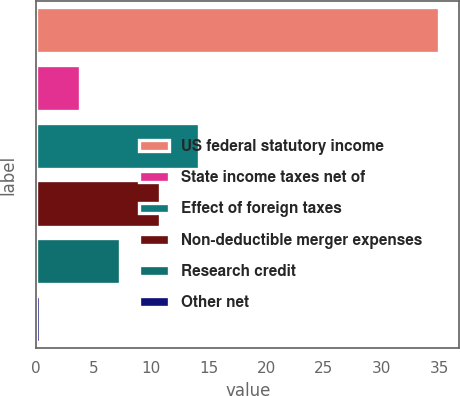Convert chart. <chart><loc_0><loc_0><loc_500><loc_500><bar_chart><fcel>US federal statutory income<fcel>State income taxes net of<fcel>Effect of foreign taxes<fcel>Non-deductible merger expenses<fcel>Research credit<fcel>Other net<nl><fcel>35<fcel>3.77<fcel>14.18<fcel>10.71<fcel>7.24<fcel>0.3<nl></chart> 